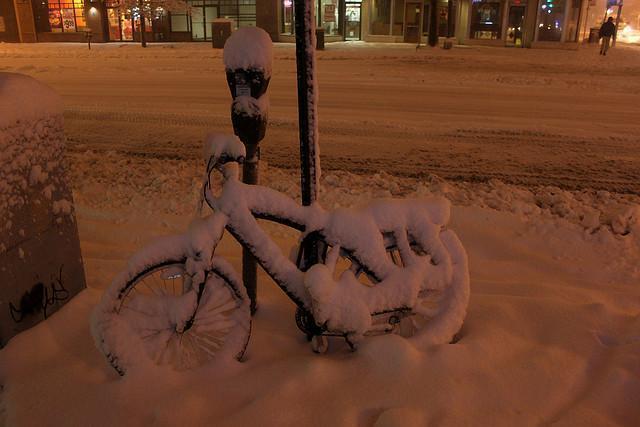How much did the owner of this bike put into the parking meter here?
From the following four choices, select the correct answer to address the question.
Options: $1, .25, penny, none. None. 